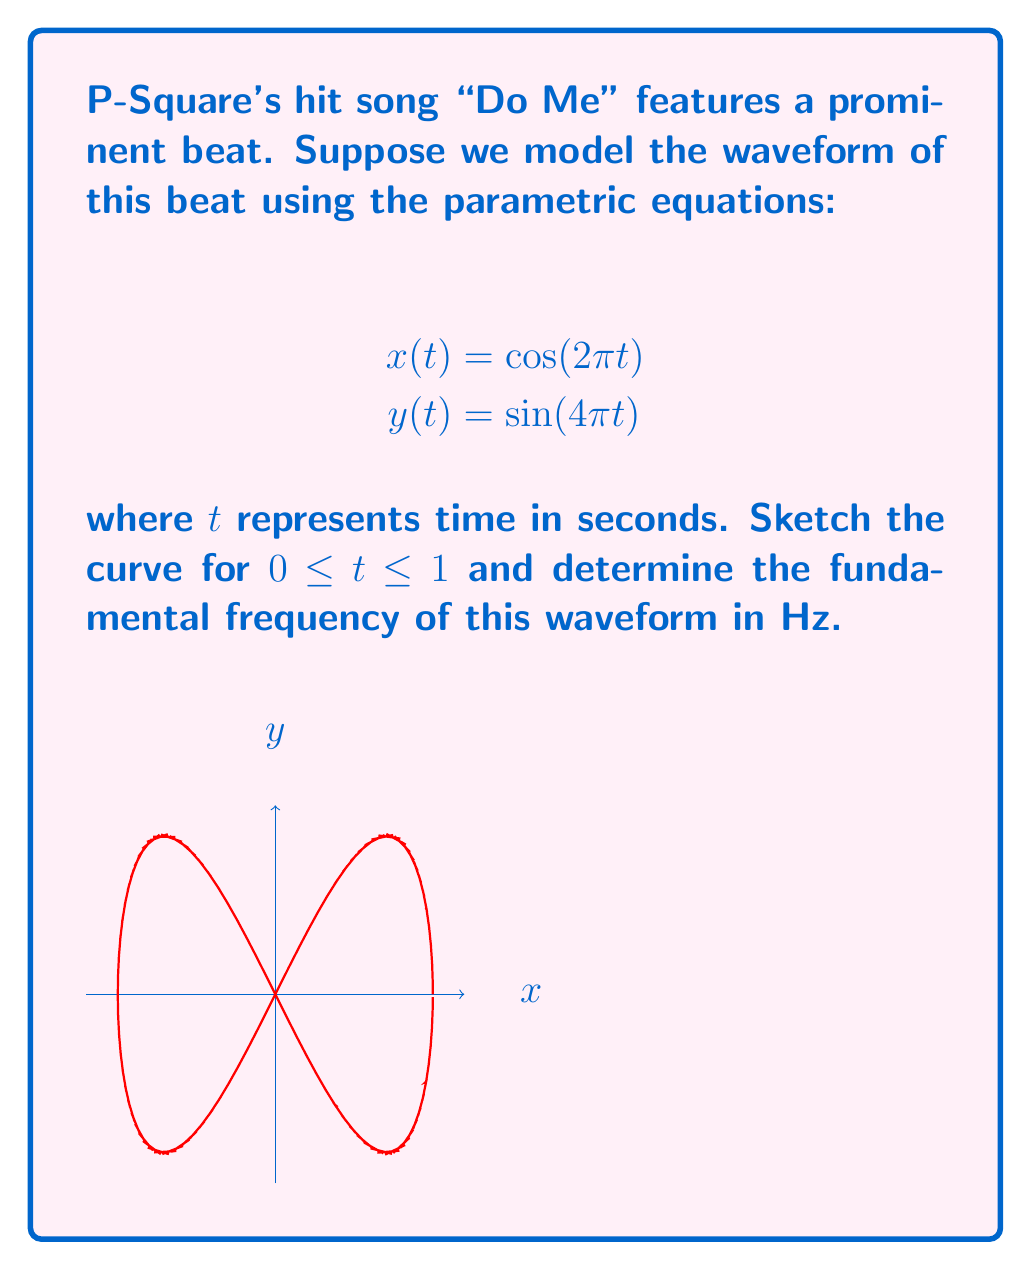Can you answer this question? To analyze this problem, let's follow these steps:

1) First, we need to understand what the curve represents. The parametric equations describe a figure-eight pattern, which is characteristic of a frequency-doubled signal.

2) To determine the fundamental frequency, we need to find the period of the waveform. This is the time it takes for the pattern to repeat.

3) Looking at the x-component:
   $$x(t) = \cos(2\pi t)$$
   This has a period of 1 second, as $\cos(2\pi(t+1)) = \cos(2\pi t)$.

4) The y-component:
   $$y(t) = \sin(4\pi t)$$
   This has a period of 0.5 seconds, as $\sin(4\pi(t+0.5)) = \sin(4\pi t)$.

5) The overall pattern will repeat when both x and y components complete full cycles. This occurs after 1 second, which is the least common multiple of 1 and 0.5.

6) The fundamental frequency is the reciprocal of the period. So:
   
   Fundamental Frequency = $\frac{1}{\text{Period}} = \frac{1}{1\text{ s}} = 1\text{ Hz}$

This 1 Hz frequency corresponds to the x-component, while the y-component represents its first harmonic at 2 Hz, creating the frequency-doubled pattern characteristic of many electronic beats in pop music.
Answer: 1 Hz 